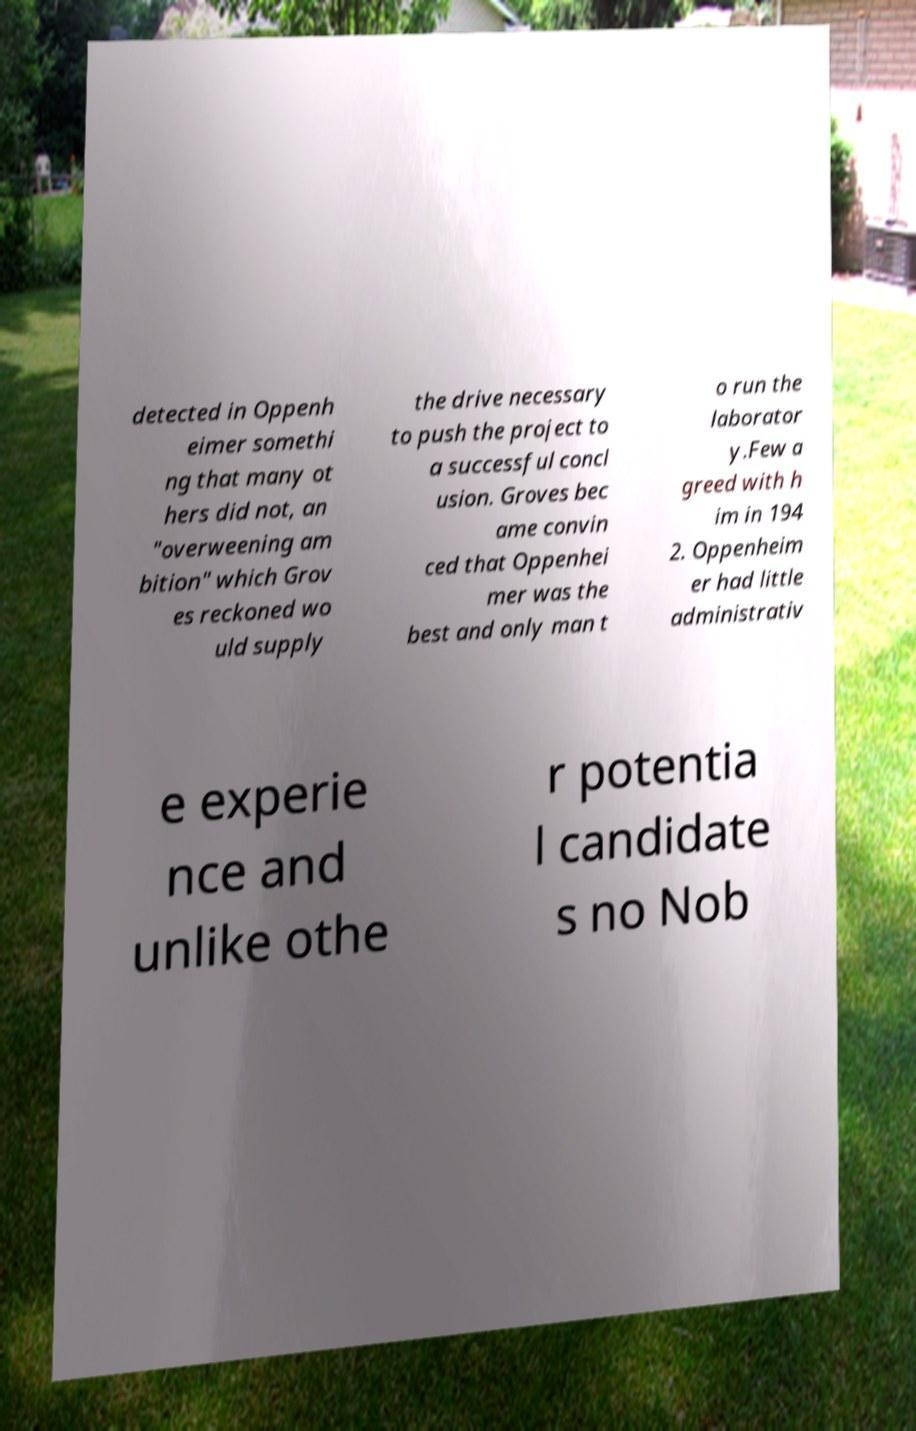There's text embedded in this image that I need extracted. Can you transcribe it verbatim? detected in Oppenh eimer somethi ng that many ot hers did not, an "overweening am bition" which Grov es reckoned wo uld supply the drive necessary to push the project to a successful concl usion. Groves bec ame convin ced that Oppenhei mer was the best and only man t o run the laborator y.Few a greed with h im in 194 2. Oppenheim er had little administrativ e experie nce and unlike othe r potentia l candidate s no Nob 